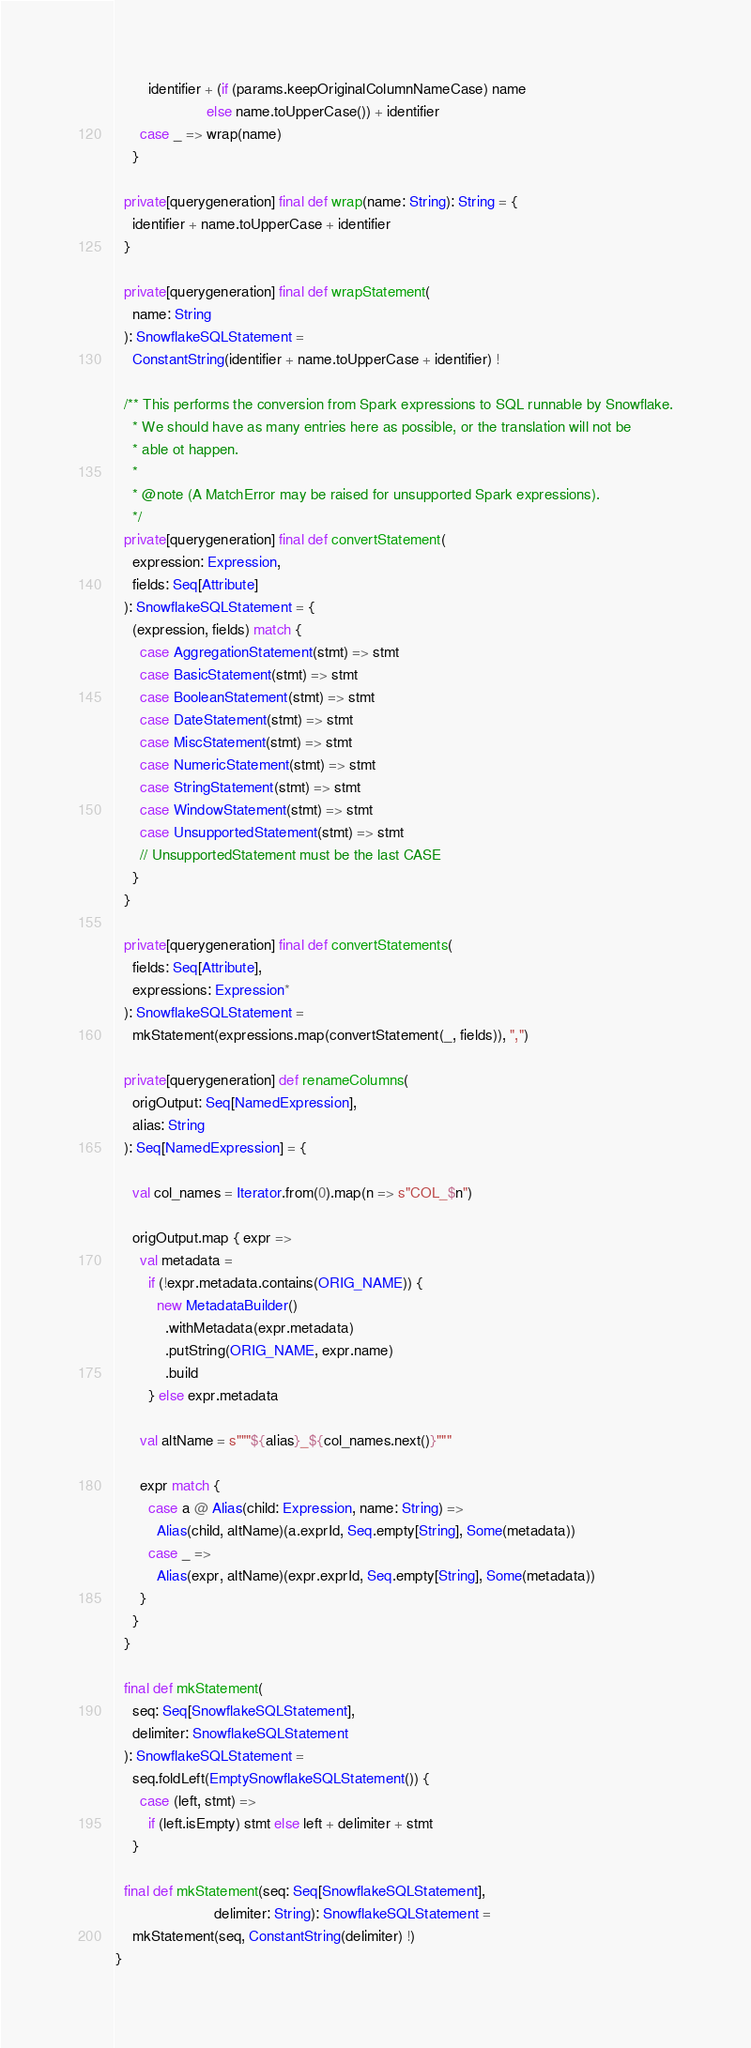<code> <loc_0><loc_0><loc_500><loc_500><_Scala_>        identifier + (if (params.keepOriginalColumnNameCase) name
                      else name.toUpperCase()) + identifier
      case _ => wrap(name)
    }

  private[querygeneration] final def wrap(name: String): String = {
    identifier + name.toUpperCase + identifier
  }

  private[querygeneration] final def wrapStatement(
    name: String
  ): SnowflakeSQLStatement =
    ConstantString(identifier + name.toUpperCase + identifier) !

  /** This performs the conversion from Spark expressions to SQL runnable by Snowflake.
    * We should have as many entries here as possible, or the translation will not be
    * able ot happen.
    *
    * @note (A MatchError may be raised for unsupported Spark expressions).
    */
  private[querygeneration] final def convertStatement(
    expression: Expression,
    fields: Seq[Attribute]
  ): SnowflakeSQLStatement = {
    (expression, fields) match {
      case AggregationStatement(stmt) => stmt
      case BasicStatement(stmt) => stmt
      case BooleanStatement(stmt) => stmt
      case DateStatement(stmt) => stmt
      case MiscStatement(stmt) => stmt
      case NumericStatement(stmt) => stmt
      case StringStatement(stmt) => stmt
      case WindowStatement(stmt) => stmt
      case UnsupportedStatement(stmt) => stmt
      // UnsupportedStatement must be the last CASE
    }
  }

  private[querygeneration] final def convertStatements(
    fields: Seq[Attribute],
    expressions: Expression*
  ): SnowflakeSQLStatement =
    mkStatement(expressions.map(convertStatement(_, fields)), ",")

  private[querygeneration] def renameColumns(
    origOutput: Seq[NamedExpression],
    alias: String
  ): Seq[NamedExpression] = {

    val col_names = Iterator.from(0).map(n => s"COL_$n")

    origOutput.map { expr =>
      val metadata =
        if (!expr.metadata.contains(ORIG_NAME)) {
          new MetadataBuilder()
            .withMetadata(expr.metadata)
            .putString(ORIG_NAME, expr.name)
            .build
        } else expr.metadata

      val altName = s"""${alias}_${col_names.next()}"""

      expr match {
        case a @ Alias(child: Expression, name: String) =>
          Alias(child, altName)(a.exprId, Seq.empty[String], Some(metadata))
        case _ =>
          Alias(expr, altName)(expr.exprId, Seq.empty[String], Some(metadata))
      }
    }
  }

  final def mkStatement(
    seq: Seq[SnowflakeSQLStatement],
    delimiter: SnowflakeSQLStatement
  ): SnowflakeSQLStatement =
    seq.foldLeft(EmptySnowflakeSQLStatement()) {
      case (left, stmt) =>
        if (left.isEmpty) stmt else left + delimiter + stmt
    }

  final def mkStatement(seq: Seq[SnowflakeSQLStatement],
                        delimiter: String): SnowflakeSQLStatement =
    mkStatement(seq, ConstantString(delimiter) !)
}
</code> 